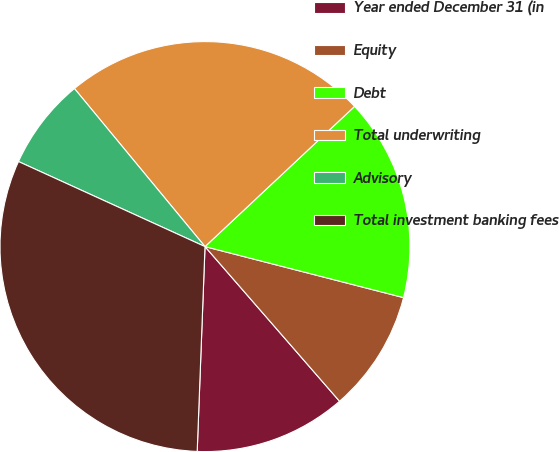Convert chart to OTSL. <chart><loc_0><loc_0><loc_500><loc_500><pie_chart><fcel>Year ended December 31 (in<fcel>Equity<fcel>Debt<fcel>Total underwriting<fcel>Advisory<fcel>Total investment banking fees<nl><fcel>12.0%<fcel>9.6%<fcel>15.99%<fcel>24.0%<fcel>7.2%<fcel>31.2%<nl></chart> 